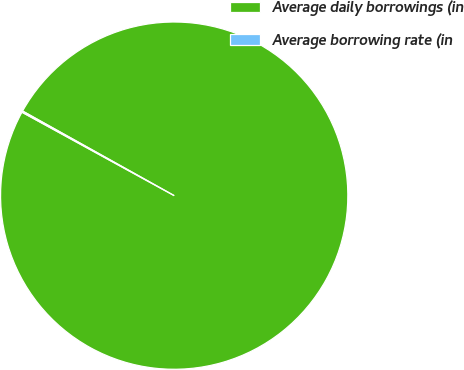Convert chart. <chart><loc_0><loc_0><loc_500><loc_500><pie_chart><fcel>Average daily borrowings (in<fcel>Average borrowing rate (in<nl><fcel>99.88%<fcel>0.12%<nl></chart> 